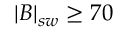Convert formula to latex. <formula><loc_0><loc_0><loc_500><loc_500>| B | _ { s w } \geq 7 0</formula> 